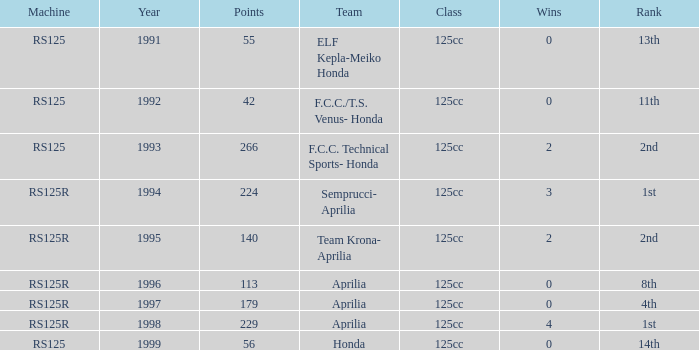In which class can a machine with an rs125r, more than 113 points, and a 4th position be found? 125cc. 